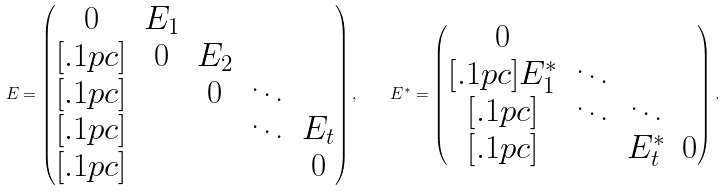<formula> <loc_0><loc_0><loc_500><loc_500>E = \begin{pmatrix} 0 & E _ { 1 } \\ [ . 1 p c ] & 0 & E _ { 2 } \\ [ . 1 p c ] & & 0 & \ddots \\ [ . 1 p c ] & & & \ddots & E _ { t } \\ [ . 1 p c ] & & & & 0 \end{pmatrix} , \quad E ^ { \ast } = \begin{pmatrix} 0 & \\ [ . 1 p c ] E _ { 1 } ^ { \ast } & \ddots \\ [ . 1 p c ] & \ddots & \ddots \\ [ . 1 p c ] & & E _ { t } ^ { \ast } & 0 \end{pmatrix} .</formula> 